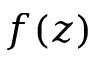<formula> <loc_0><loc_0><loc_500><loc_500>f ( z )</formula> 